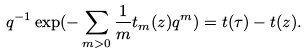Convert formula to latex. <formula><loc_0><loc_0><loc_500><loc_500>q ^ { - 1 } \exp ( - \sum _ { m > 0 } \frac { 1 } { m } t _ { m } ( z ) q ^ { m } ) = t ( \tau ) - t ( z ) .</formula> 